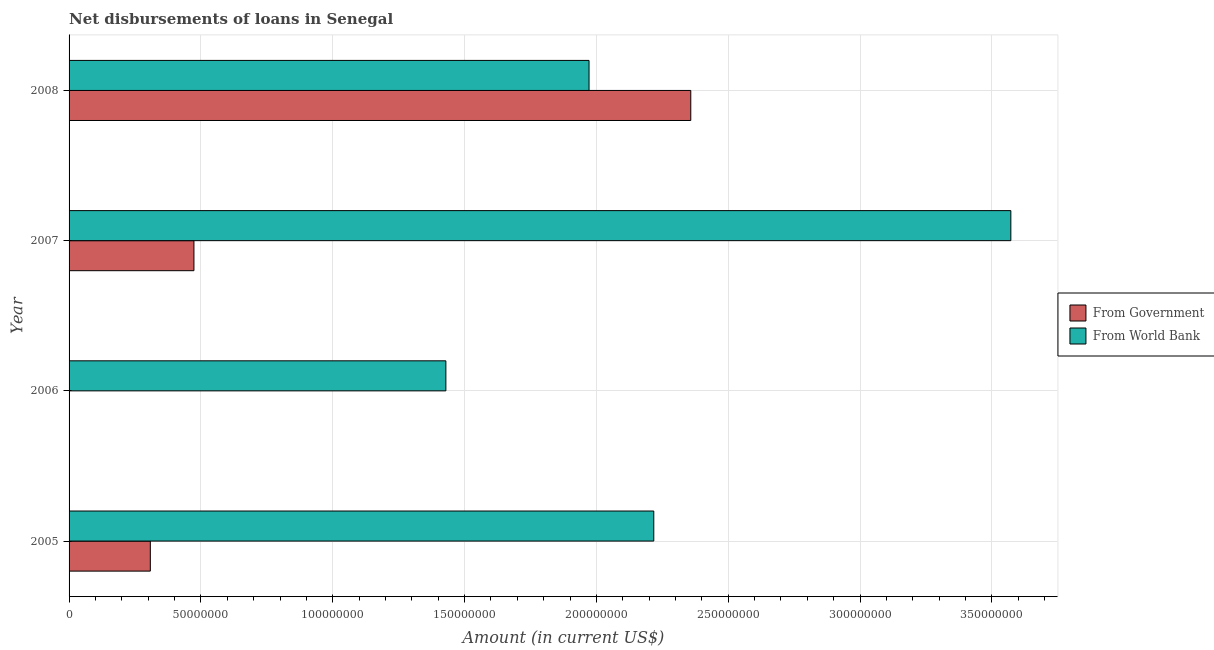How many different coloured bars are there?
Offer a very short reply. 2. Are the number of bars per tick equal to the number of legend labels?
Offer a terse response. No. How many bars are there on the 2nd tick from the bottom?
Your response must be concise. 1. What is the net disbursements of loan from government in 2006?
Your answer should be very brief. 0. Across all years, what is the maximum net disbursements of loan from world bank?
Offer a very short reply. 3.57e+08. In which year was the net disbursements of loan from government maximum?
Make the answer very short. 2008. What is the total net disbursements of loan from world bank in the graph?
Make the answer very short. 9.19e+08. What is the difference between the net disbursements of loan from government in 2005 and that in 2008?
Offer a very short reply. -2.05e+08. What is the difference between the net disbursements of loan from government in 2008 and the net disbursements of loan from world bank in 2007?
Your response must be concise. -1.21e+08. What is the average net disbursements of loan from world bank per year?
Offer a very short reply. 2.30e+08. In the year 2005, what is the difference between the net disbursements of loan from government and net disbursements of loan from world bank?
Keep it short and to the point. -1.91e+08. In how many years, is the net disbursements of loan from world bank greater than 100000000 US$?
Make the answer very short. 4. What is the ratio of the net disbursements of loan from world bank in 2007 to that in 2008?
Your response must be concise. 1.81. Is the net disbursements of loan from world bank in 2005 less than that in 2006?
Your answer should be very brief. No. What is the difference between the highest and the second highest net disbursements of loan from world bank?
Keep it short and to the point. 1.35e+08. What is the difference between the highest and the lowest net disbursements of loan from world bank?
Provide a short and direct response. 2.14e+08. Is the sum of the net disbursements of loan from world bank in 2005 and 2008 greater than the maximum net disbursements of loan from government across all years?
Your answer should be very brief. Yes. Are all the bars in the graph horizontal?
Give a very brief answer. Yes. What is the difference between two consecutive major ticks on the X-axis?
Ensure brevity in your answer.  5.00e+07. Does the graph contain any zero values?
Give a very brief answer. Yes. Does the graph contain grids?
Provide a short and direct response. Yes. Where does the legend appear in the graph?
Make the answer very short. Center right. How many legend labels are there?
Offer a terse response. 2. What is the title of the graph?
Offer a terse response. Net disbursements of loans in Senegal. Does "Young" appear as one of the legend labels in the graph?
Provide a short and direct response. No. What is the label or title of the X-axis?
Your response must be concise. Amount (in current US$). What is the Amount (in current US$) in From Government in 2005?
Offer a terse response. 3.08e+07. What is the Amount (in current US$) of From World Bank in 2005?
Give a very brief answer. 2.22e+08. What is the Amount (in current US$) in From Government in 2006?
Keep it short and to the point. 0. What is the Amount (in current US$) in From World Bank in 2006?
Provide a succinct answer. 1.43e+08. What is the Amount (in current US$) of From Government in 2007?
Your answer should be compact. 4.74e+07. What is the Amount (in current US$) in From World Bank in 2007?
Offer a terse response. 3.57e+08. What is the Amount (in current US$) of From Government in 2008?
Ensure brevity in your answer.  2.36e+08. What is the Amount (in current US$) in From World Bank in 2008?
Your answer should be very brief. 1.97e+08. Across all years, what is the maximum Amount (in current US$) in From Government?
Your response must be concise. 2.36e+08. Across all years, what is the maximum Amount (in current US$) in From World Bank?
Keep it short and to the point. 3.57e+08. Across all years, what is the minimum Amount (in current US$) of From Government?
Your answer should be compact. 0. Across all years, what is the minimum Amount (in current US$) of From World Bank?
Provide a short and direct response. 1.43e+08. What is the total Amount (in current US$) in From Government in the graph?
Give a very brief answer. 3.14e+08. What is the total Amount (in current US$) of From World Bank in the graph?
Give a very brief answer. 9.19e+08. What is the difference between the Amount (in current US$) in From World Bank in 2005 and that in 2006?
Keep it short and to the point. 7.89e+07. What is the difference between the Amount (in current US$) in From Government in 2005 and that in 2007?
Your answer should be very brief. -1.65e+07. What is the difference between the Amount (in current US$) in From World Bank in 2005 and that in 2007?
Ensure brevity in your answer.  -1.35e+08. What is the difference between the Amount (in current US$) in From Government in 2005 and that in 2008?
Give a very brief answer. -2.05e+08. What is the difference between the Amount (in current US$) of From World Bank in 2005 and that in 2008?
Keep it short and to the point. 2.46e+07. What is the difference between the Amount (in current US$) of From World Bank in 2006 and that in 2007?
Keep it short and to the point. -2.14e+08. What is the difference between the Amount (in current US$) in From World Bank in 2006 and that in 2008?
Keep it short and to the point. -5.43e+07. What is the difference between the Amount (in current US$) of From Government in 2007 and that in 2008?
Keep it short and to the point. -1.88e+08. What is the difference between the Amount (in current US$) in From World Bank in 2007 and that in 2008?
Provide a succinct answer. 1.60e+08. What is the difference between the Amount (in current US$) of From Government in 2005 and the Amount (in current US$) of From World Bank in 2006?
Make the answer very short. -1.12e+08. What is the difference between the Amount (in current US$) of From Government in 2005 and the Amount (in current US$) of From World Bank in 2007?
Offer a very short reply. -3.26e+08. What is the difference between the Amount (in current US$) in From Government in 2005 and the Amount (in current US$) in From World Bank in 2008?
Make the answer very short. -1.66e+08. What is the difference between the Amount (in current US$) of From Government in 2007 and the Amount (in current US$) of From World Bank in 2008?
Give a very brief answer. -1.50e+08. What is the average Amount (in current US$) of From Government per year?
Offer a very short reply. 7.85e+07. What is the average Amount (in current US$) of From World Bank per year?
Ensure brevity in your answer.  2.30e+08. In the year 2005, what is the difference between the Amount (in current US$) in From Government and Amount (in current US$) in From World Bank?
Offer a terse response. -1.91e+08. In the year 2007, what is the difference between the Amount (in current US$) of From Government and Amount (in current US$) of From World Bank?
Make the answer very short. -3.10e+08. In the year 2008, what is the difference between the Amount (in current US$) of From Government and Amount (in current US$) of From World Bank?
Give a very brief answer. 3.86e+07. What is the ratio of the Amount (in current US$) of From World Bank in 2005 to that in 2006?
Offer a very short reply. 1.55. What is the ratio of the Amount (in current US$) of From Government in 2005 to that in 2007?
Provide a short and direct response. 0.65. What is the ratio of the Amount (in current US$) of From World Bank in 2005 to that in 2007?
Keep it short and to the point. 0.62. What is the ratio of the Amount (in current US$) of From Government in 2005 to that in 2008?
Your answer should be very brief. 0.13. What is the ratio of the Amount (in current US$) in From World Bank in 2005 to that in 2008?
Offer a very short reply. 1.12. What is the ratio of the Amount (in current US$) of From World Bank in 2006 to that in 2007?
Your response must be concise. 0.4. What is the ratio of the Amount (in current US$) of From World Bank in 2006 to that in 2008?
Provide a short and direct response. 0.72. What is the ratio of the Amount (in current US$) of From Government in 2007 to that in 2008?
Your answer should be compact. 0.2. What is the ratio of the Amount (in current US$) in From World Bank in 2007 to that in 2008?
Ensure brevity in your answer.  1.81. What is the difference between the highest and the second highest Amount (in current US$) of From Government?
Give a very brief answer. 1.88e+08. What is the difference between the highest and the second highest Amount (in current US$) of From World Bank?
Make the answer very short. 1.35e+08. What is the difference between the highest and the lowest Amount (in current US$) of From Government?
Make the answer very short. 2.36e+08. What is the difference between the highest and the lowest Amount (in current US$) of From World Bank?
Keep it short and to the point. 2.14e+08. 